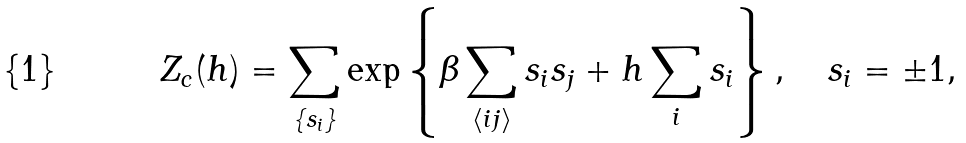Convert formula to latex. <formula><loc_0><loc_0><loc_500><loc_500>Z _ { c } ( h ) = \sum _ { \{ s _ { i } \} } \exp \left \{ \beta \sum _ { \langle i j \rangle } s _ { i } s _ { j } + h \sum _ { i } s _ { i } \right \} , \quad s _ { i } = \pm 1 ,</formula> 